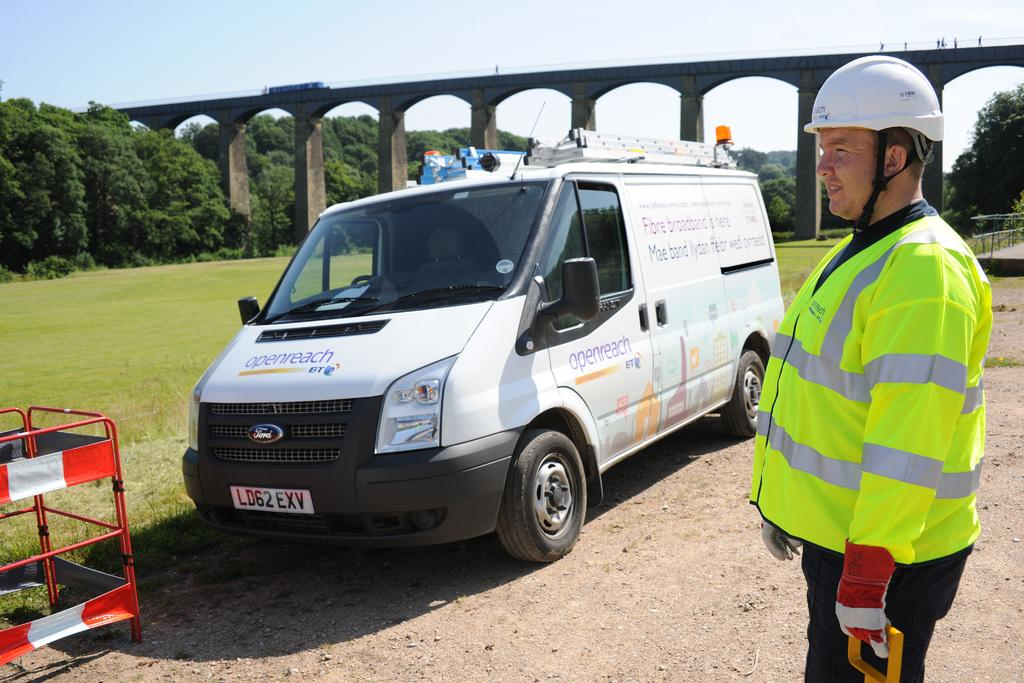<image>
Describe the image concisely. A maintenance worker in front of his van with the logo of the company Openreach. 